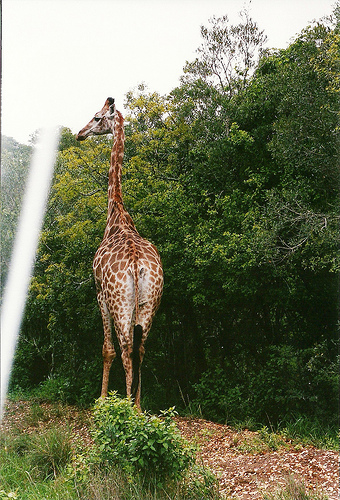<image>
Can you confirm if the giraffe is in the tree? No. The giraffe is not contained within the tree. These objects have a different spatial relationship. 